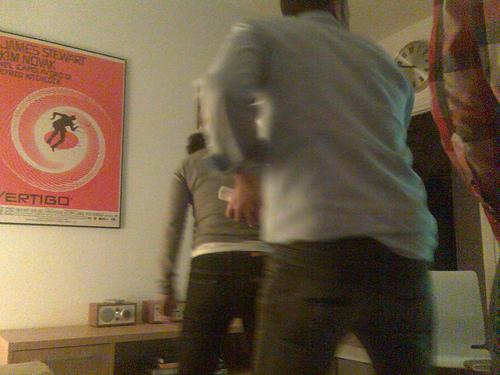What form of vintage media do the people in the living room enjoy? movies 